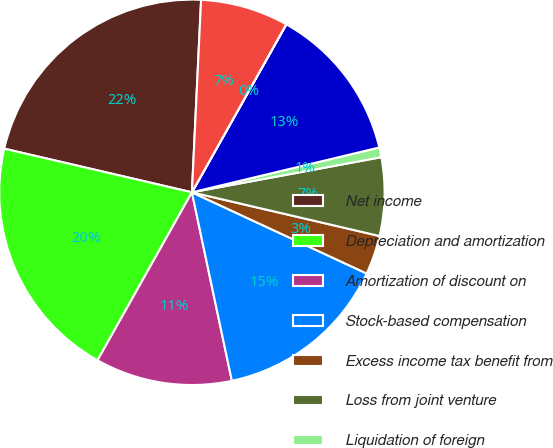<chart> <loc_0><loc_0><loc_500><loc_500><pie_chart><fcel>Net income<fcel>Depreciation and amortization<fcel>Amortization of discount on<fcel>Stock-based compensation<fcel>Excess income tax benefit from<fcel>Loss from joint venture<fcel>Liquidation of foreign<fcel>Trade accounts receivable net<fcel>Inventories<fcel>Accounts payable<nl><fcel>22.12%<fcel>20.49%<fcel>11.47%<fcel>14.75%<fcel>3.28%<fcel>6.56%<fcel>0.82%<fcel>13.11%<fcel>0.01%<fcel>7.38%<nl></chart> 